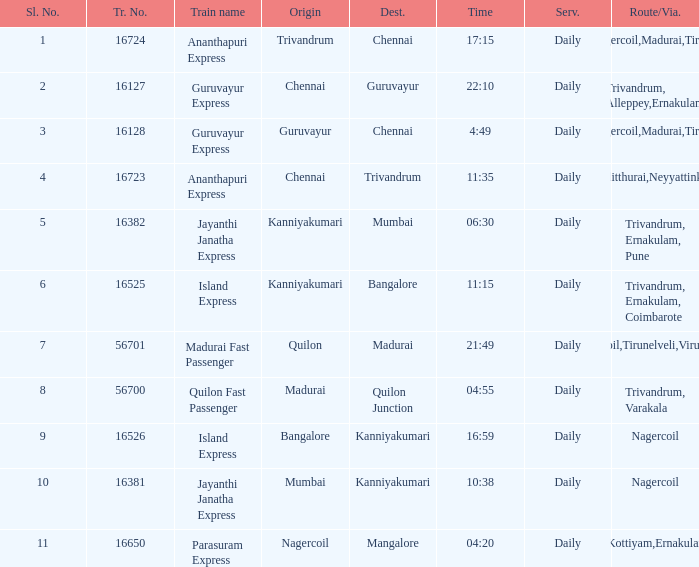What is the route/via when the destination is listed as Madurai? Nagercoil,Tirunelveli,Virudunagar. 